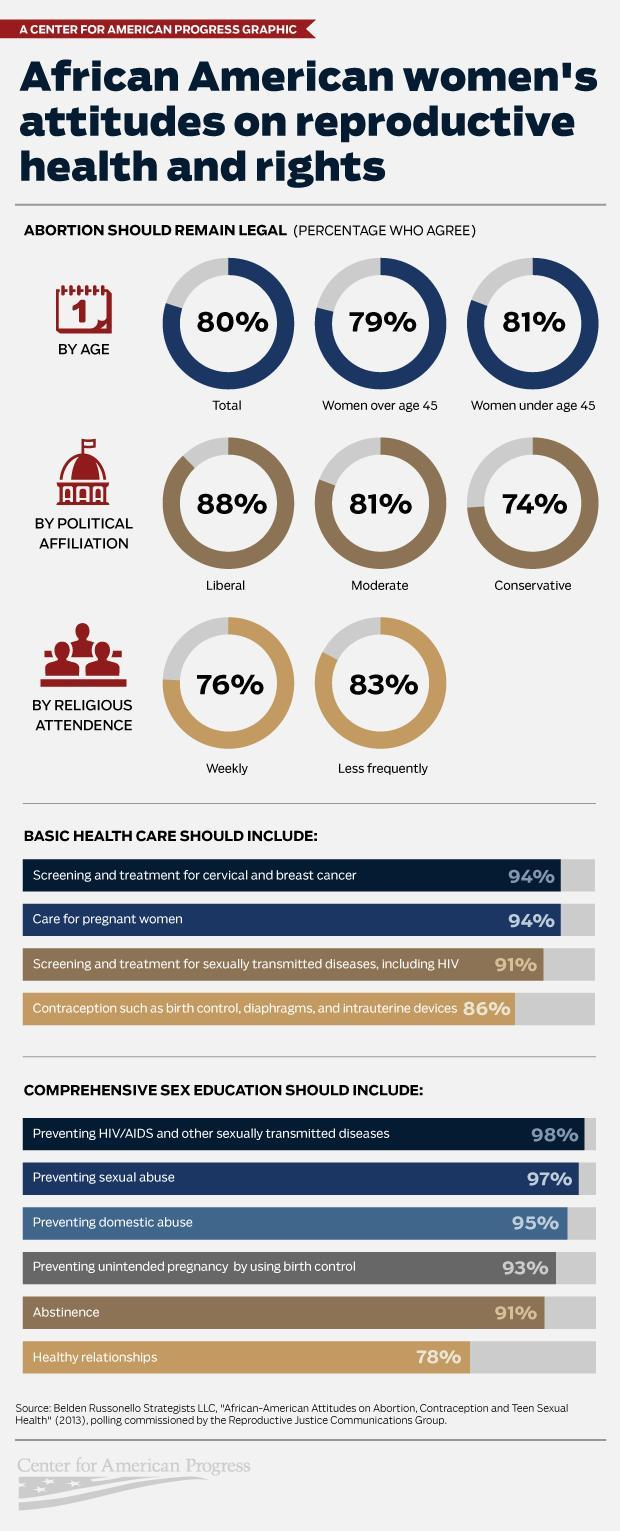What percentage of African American women do not agree that basic health care should include screening & treatment for cervical & breast cancer?
Answer the question with a short phrase. 6% What percentage of African American women do not agree that comprehensive sex education should include abstinence? 9% What percentage of African American women under age 45 agree that abortion should remain legal? 81% What percentage of African American women over age 45 agree that abortion should remain legal? 79% What percentage of African American women who pay weekly visits to religious places agree that abortion should remain legal? 76% What percentage of  African American women agree that basic health care should include care for pregnant women? 94% What percentage of African American women do not agree that comprehensive sex education should include preventing sexual abuse? 3% 